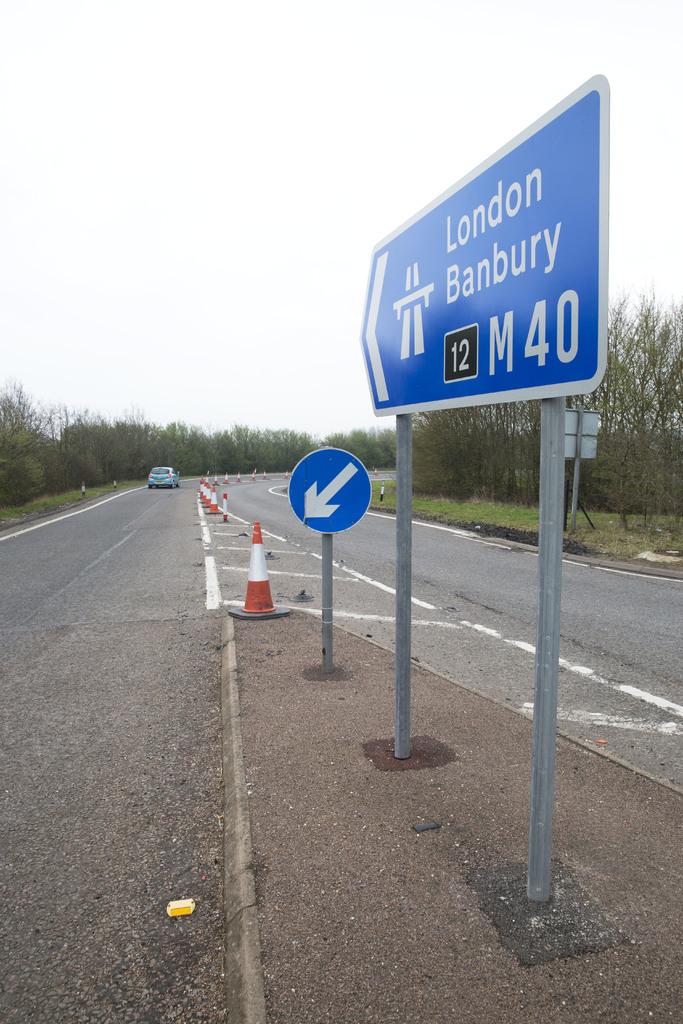Where does this road lead?
Your answer should be very brief. London banbury. What is the name of the road?
Your answer should be compact. London banbury. 